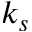<formula> <loc_0><loc_0><loc_500><loc_500>k _ { s }</formula> 